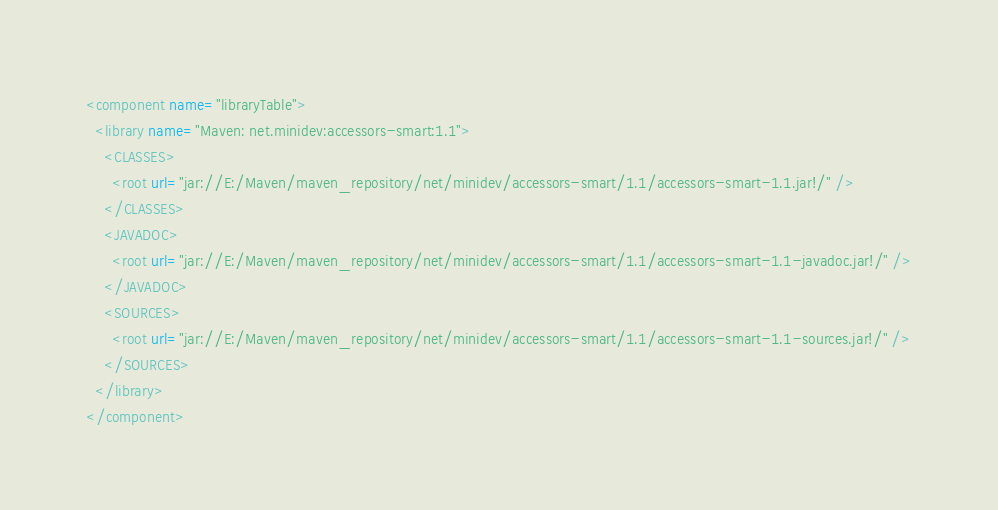Convert code to text. <code><loc_0><loc_0><loc_500><loc_500><_XML_><component name="libraryTable">
  <library name="Maven: net.minidev:accessors-smart:1.1">
    <CLASSES>
      <root url="jar://E:/Maven/maven_repository/net/minidev/accessors-smart/1.1/accessors-smart-1.1.jar!/" />
    </CLASSES>
    <JAVADOC>
      <root url="jar://E:/Maven/maven_repository/net/minidev/accessors-smart/1.1/accessors-smart-1.1-javadoc.jar!/" />
    </JAVADOC>
    <SOURCES>
      <root url="jar://E:/Maven/maven_repository/net/minidev/accessors-smart/1.1/accessors-smart-1.1-sources.jar!/" />
    </SOURCES>
  </library>
</component></code> 